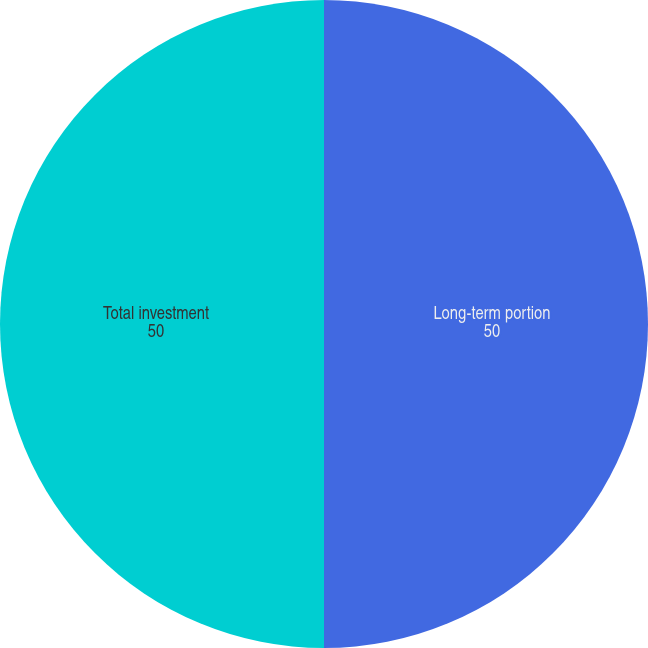Convert chart to OTSL. <chart><loc_0><loc_0><loc_500><loc_500><pie_chart><fcel>Long-term portion<fcel>Total investment<nl><fcel>50.0%<fcel>50.0%<nl></chart> 